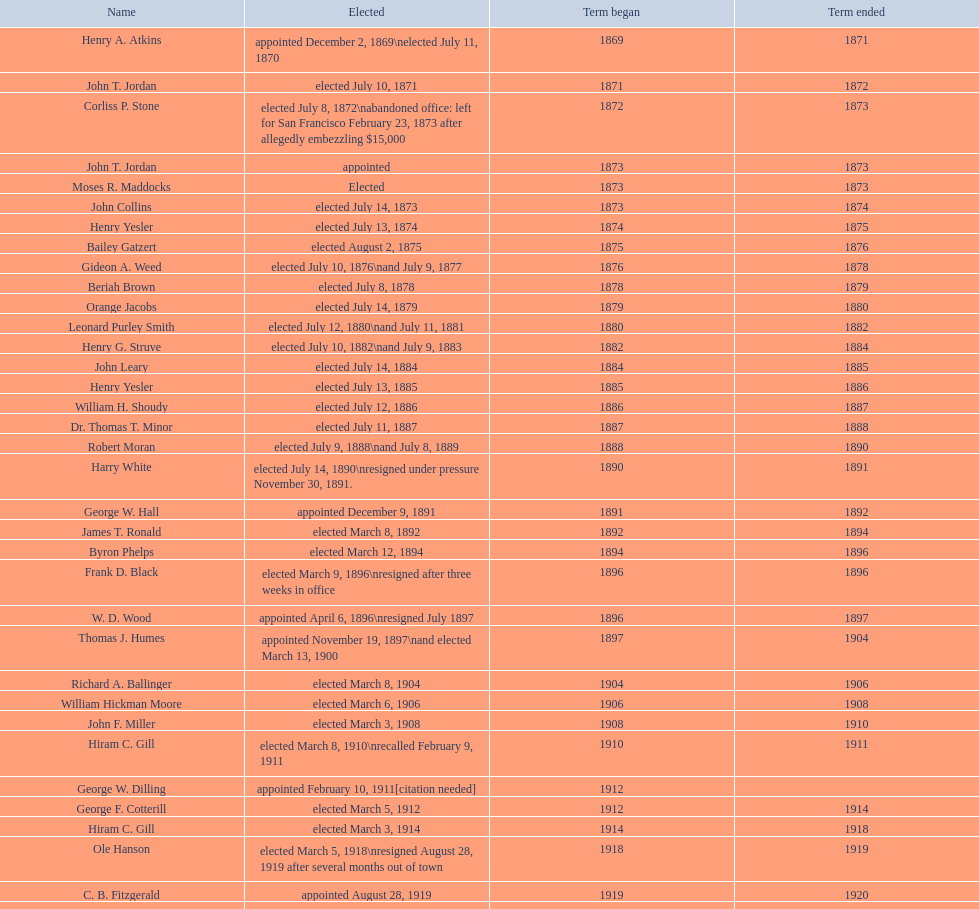Did charles royer hold office longer than paul schell? Yes. Can you give me this table as a dict? {'header': ['Name', 'Elected', 'Term began', 'Term ended'], 'rows': [['Henry A. Atkins', 'appointed December 2, 1869\\nelected July 11, 1870', '1869', '1871'], ['John T. Jordan', 'elected July 10, 1871', '1871', '1872'], ['Corliss P. Stone', 'elected July 8, 1872\\nabandoned office: left for San Francisco February 23, 1873 after allegedly embezzling $15,000', '1872', '1873'], ['John T. Jordan', 'appointed', '1873', '1873'], ['Moses R. Maddocks', 'Elected', '1873', '1873'], ['John Collins', 'elected July 14, 1873', '1873', '1874'], ['Henry Yesler', 'elected July 13, 1874', '1874', '1875'], ['Bailey Gatzert', 'elected August 2, 1875', '1875', '1876'], ['Gideon A. Weed', 'elected July 10, 1876\\nand July 9, 1877', '1876', '1878'], ['Beriah Brown', 'elected July 8, 1878', '1878', '1879'], ['Orange Jacobs', 'elected July 14, 1879', '1879', '1880'], ['Leonard Purley Smith', 'elected July 12, 1880\\nand July 11, 1881', '1880', '1882'], ['Henry G. Struve', 'elected July 10, 1882\\nand July 9, 1883', '1882', '1884'], ['John Leary', 'elected July 14, 1884', '1884', '1885'], ['Henry Yesler', 'elected July 13, 1885', '1885', '1886'], ['William H. Shoudy', 'elected July 12, 1886', '1886', '1887'], ['Dr. Thomas T. Minor', 'elected July 11, 1887', '1887', '1888'], ['Robert Moran', 'elected July 9, 1888\\nand July 8, 1889', '1888', '1890'], ['Harry White', 'elected July 14, 1890\\nresigned under pressure November 30, 1891.', '1890', '1891'], ['George W. Hall', 'appointed December 9, 1891', '1891', '1892'], ['James T. Ronald', 'elected March 8, 1892', '1892', '1894'], ['Byron Phelps', 'elected March 12, 1894', '1894', '1896'], ['Frank D. Black', 'elected March 9, 1896\\nresigned after three weeks in office', '1896', '1896'], ['W. D. Wood', 'appointed April 6, 1896\\nresigned July 1897', '1896', '1897'], ['Thomas J. Humes', 'appointed November 19, 1897\\nand elected March 13, 1900', '1897', '1904'], ['Richard A. Ballinger', 'elected March 8, 1904', '1904', '1906'], ['William Hickman Moore', 'elected March 6, 1906', '1906', '1908'], ['John F. Miller', 'elected March 3, 1908', '1908', '1910'], ['Hiram C. Gill', 'elected March 8, 1910\\nrecalled February 9, 1911', '1910', '1911'], ['George W. Dilling', 'appointed February 10, 1911[citation needed]', '1912', ''], ['George F. Cotterill', 'elected March 5, 1912', '1912', '1914'], ['Hiram C. Gill', 'elected March 3, 1914', '1914', '1918'], ['Ole Hanson', 'elected March 5, 1918\\nresigned August 28, 1919 after several months out of town', '1918', '1919'], ['C. B. Fitzgerald', 'appointed August 28, 1919', '1919', '1920'], ['Hugh M. Caldwell', 'elected March 2, 1920', '1920', '1922'], ['Edwin J. Brown', 'elected May 2, 1922\\nand March 4, 1924', '1922', '1926'], ['Bertha Knight Landes', 'elected March 9, 1926', '1926', '1928'], ['Frank E. Edwards', 'elected March 6, 1928\\nand March 4, 1930\\nrecalled July 13, 1931', '1928', '1931'], ['Robert H. Harlin', 'appointed July 14, 1931', '1931', '1932'], ['John F. Dore', 'elected March 8, 1932', '1932', '1934'], ['Charles L. Smith', 'elected March 6, 1934', '1934', '1936'], ['John F. Dore', 'elected March 3, 1936\\nbecame gravely ill and was relieved of office April 13, 1938, already a lame duck after the 1938 election. He died five days later.', '1936', '1938'], ['Arthur B. Langlie', "elected March 8, 1938\\nappointed to take office early, April 27, 1938, after Dore's death.\\nelected March 5, 1940\\nresigned January 11, 1941, to become Governor of Washington", '1938', '1941'], ['John E. Carroll', 'appointed January 27, 1941', '1941', '1941'], ['Earl Millikin', 'elected March 4, 1941', '1941', '1942'], ['William F. Devin', 'elected March 3, 1942, March 7, 1944, March 5, 1946, and March 2, 1948', '1942', '1952'], ['Allan Pomeroy', 'elected March 4, 1952', '1952', '1956'], ['Gordon S. Clinton', 'elected March 6, 1956\\nand March 8, 1960', '1956', '1964'], ["James d'Orma Braman", 'elected March 10, 1964\\nresigned March 23, 1969, to accept an appointment as an Assistant Secretary in the Department of Transportation in the Nixon administration.', '1964', '1969'], ['Floyd C. Miller', 'appointed March 23, 1969', '1969', '1969'], ['Wesley C. Uhlman', 'elected November 4, 1969\\nand November 6, 1973\\nsurvived recall attempt on July 1, 1975', 'December 1, 1969', 'January 1, 1978'], ['Charles Royer', 'elected November 8, 1977, November 3, 1981, and November 5, 1985', 'January 1, 1978', 'January 1, 1990'], ['Norman B. Rice', 'elected November 7, 1989', 'January 1, 1990', 'January 1, 1998'], ['Paul Schell', 'elected November 4, 1997', 'January 1, 1998', 'January 1, 2002'], ['Gregory J. Nickels', 'elected November 6, 2001\\nand November 8, 2005', 'January 1, 2002', 'January 1, 2010'], ['Michael McGinn', 'elected November 3, 2009', 'January 1, 2010', 'January 1, 2014'], ['Ed Murray', 'elected November 5, 2013', 'January 1, 2014', 'present']]} 